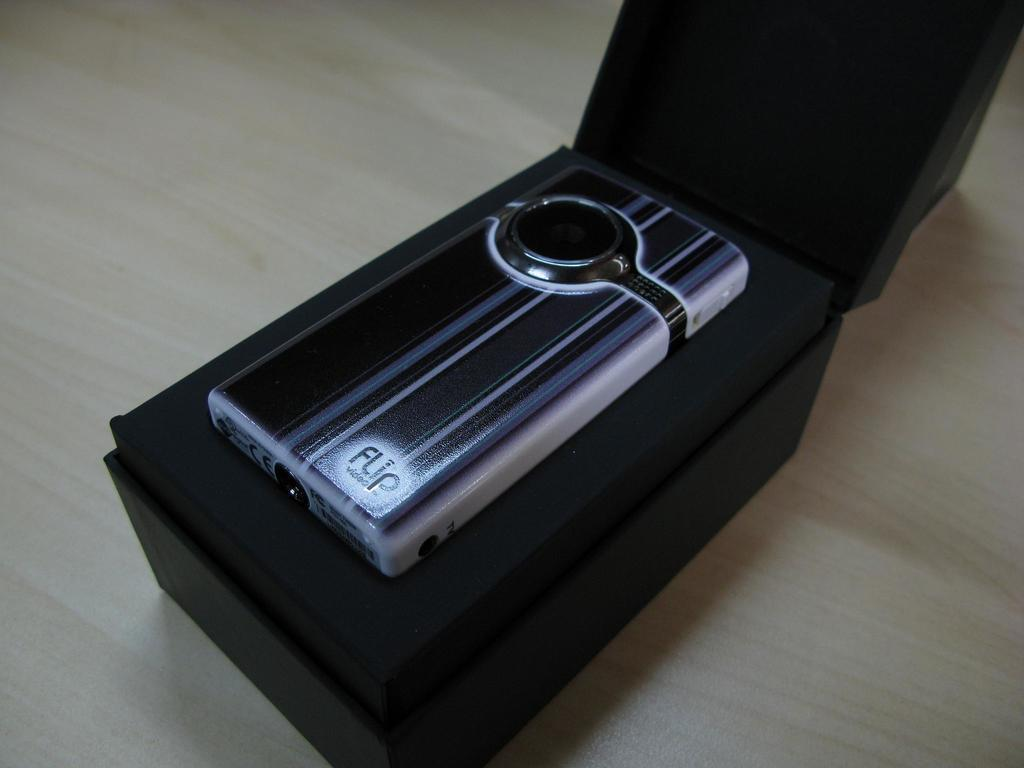What type of object is present in the image? There is an electronic gadget in the image. How is the electronic gadget packaged? The electronic gadget is in a black color box. What is the color of the surface on which the electronic gadget is placed? The electronic gadget is on a cream and white color surface. What type of border is present around the electronic gadget in the image? There is no mention of a border around the electronic gadget in the image. 